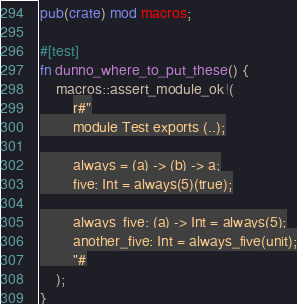<code> <loc_0><loc_0><loc_500><loc_500><_Rust_>pub(crate) mod macros;

#[test]
fn dunno_where_to_put_these() {
    macros::assert_module_ok!(
        r#"
        module Test exports (..);

        always = (a) -> (b) -> a;
        five: Int = always(5)(true);

        always_five: (a) -> Int = always(5);
        another_five: Int = always_five(unit);
        "#
    );
}
</code> 